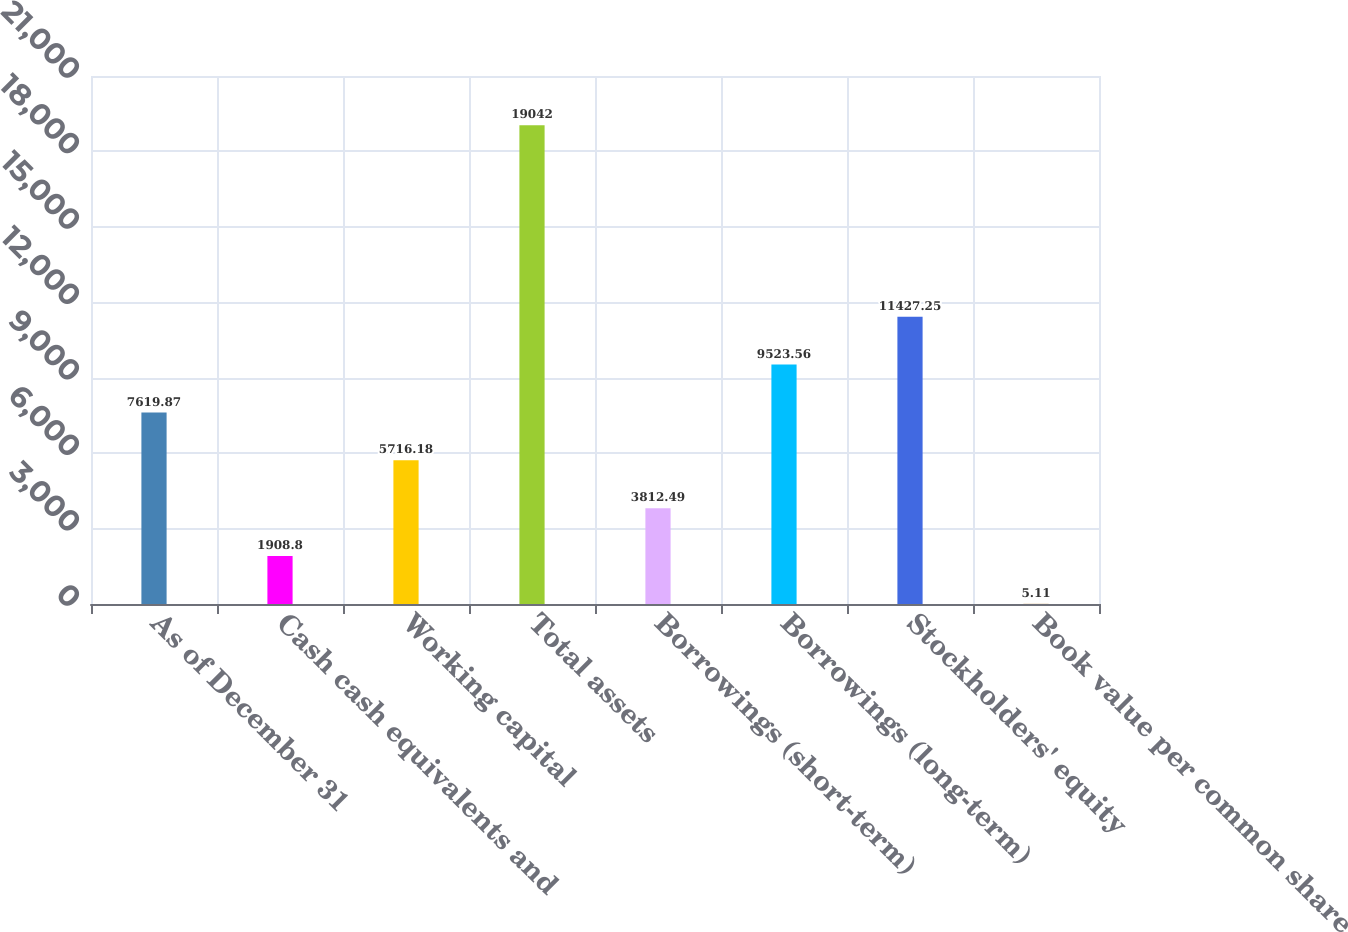Convert chart to OTSL. <chart><loc_0><loc_0><loc_500><loc_500><bar_chart><fcel>As of December 31<fcel>Cash cash equivalents and<fcel>Working capital<fcel>Total assets<fcel>Borrowings (short-term)<fcel>Borrowings (long-term)<fcel>Stockholders' equity<fcel>Book value per common share<nl><fcel>7619.87<fcel>1908.8<fcel>5716.18<fcel>19042<fcel>3812.49<fcel>9523.56<fcel>11427.2<fcel>5.11<nl></chart> 